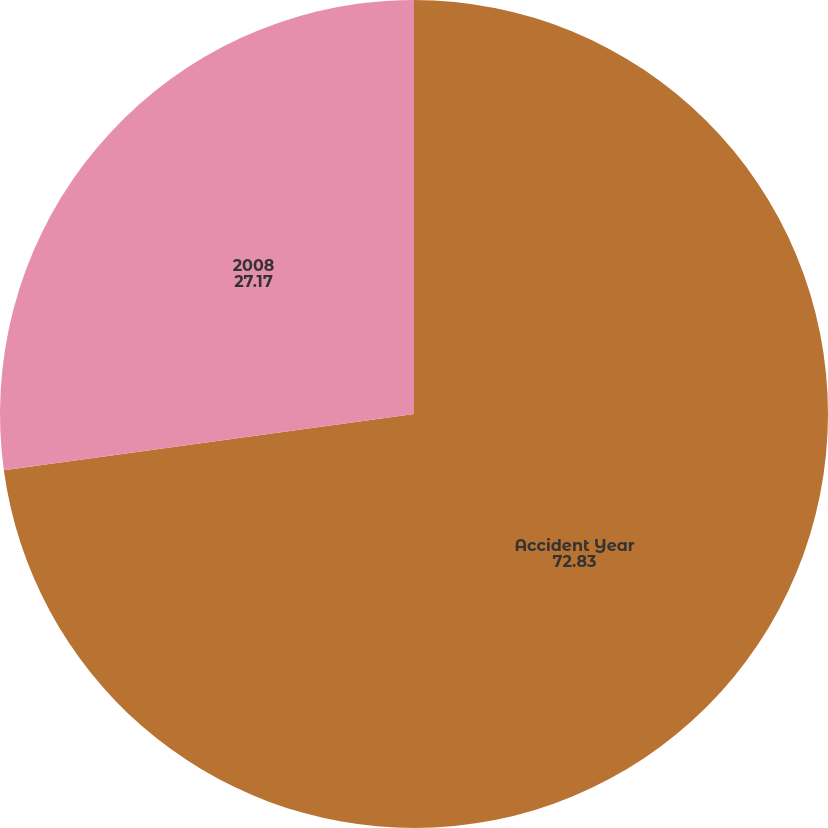<chart> <loc_0><loc_0><loc_500><loc_500><pie_chart><fcel>Accident Year<fcel>2008<nl><fcel>72.83%<fcel>27.17%<nl></chart> 